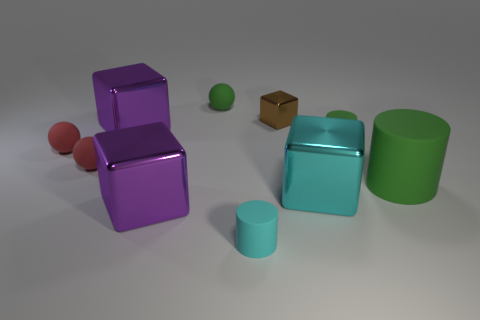Is the number of purple shiny blocks right of the big cylinder the same as the number of small green cylinders to the left of the small cyan object?
Offer a very short reply. Yes. How many things are either tiny metallic objects or purple metallic blocks that are in front of the cyan block?
Provide a succinct answer. 2. There is a rubber object that is both behind the big green object and on the right side of the brown cube; what shape is it?
Provide a succinct answer. Cylinder. What is the material of the purple thing on the right side of the big purple thing behind the cyan cube?
Your response must be concise. Metal. Is the small green thing on the left side of the tiny cyan cylinder made of the same material as the big cylinder?
Provide a succinct answer. Yes. What size is the cube that is to the right of the small metallic cube?
Your answer should be very brief. Large. There is a tiny rubber cylinder that is in front of the large green cylinder; is there a green matte object on the right side of it?
Your response must be concise. Yes. Do the small rubber cylinder that is in front of the large matte thing and the big metallic thing that is behind the big matte cylinder have the same color?
Give a very brief answer. No. The large rubber thing is what color?
Keep it short and to the point. Green. Is there anything else that is the same color as the large matte cylinder?
Provide a succinct answer. Yes. 